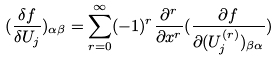Convert formula to latex. <formula><loc_0><loc_0><loc_500><loc_500>( \frac { \delta f } { \delta U _ { j } } ) _ { \alpha \beta } = \sum _ { r = 0 } ^ { \infty } ( - 1 ) ^ { r } \frac { \partial ^ { r } } { \partial x ^ { r } } ( \frac { \partial f } { \partial ( U _ { j } ^ { ( r ) } ) _ { \beta \alpha } } )</formula> 